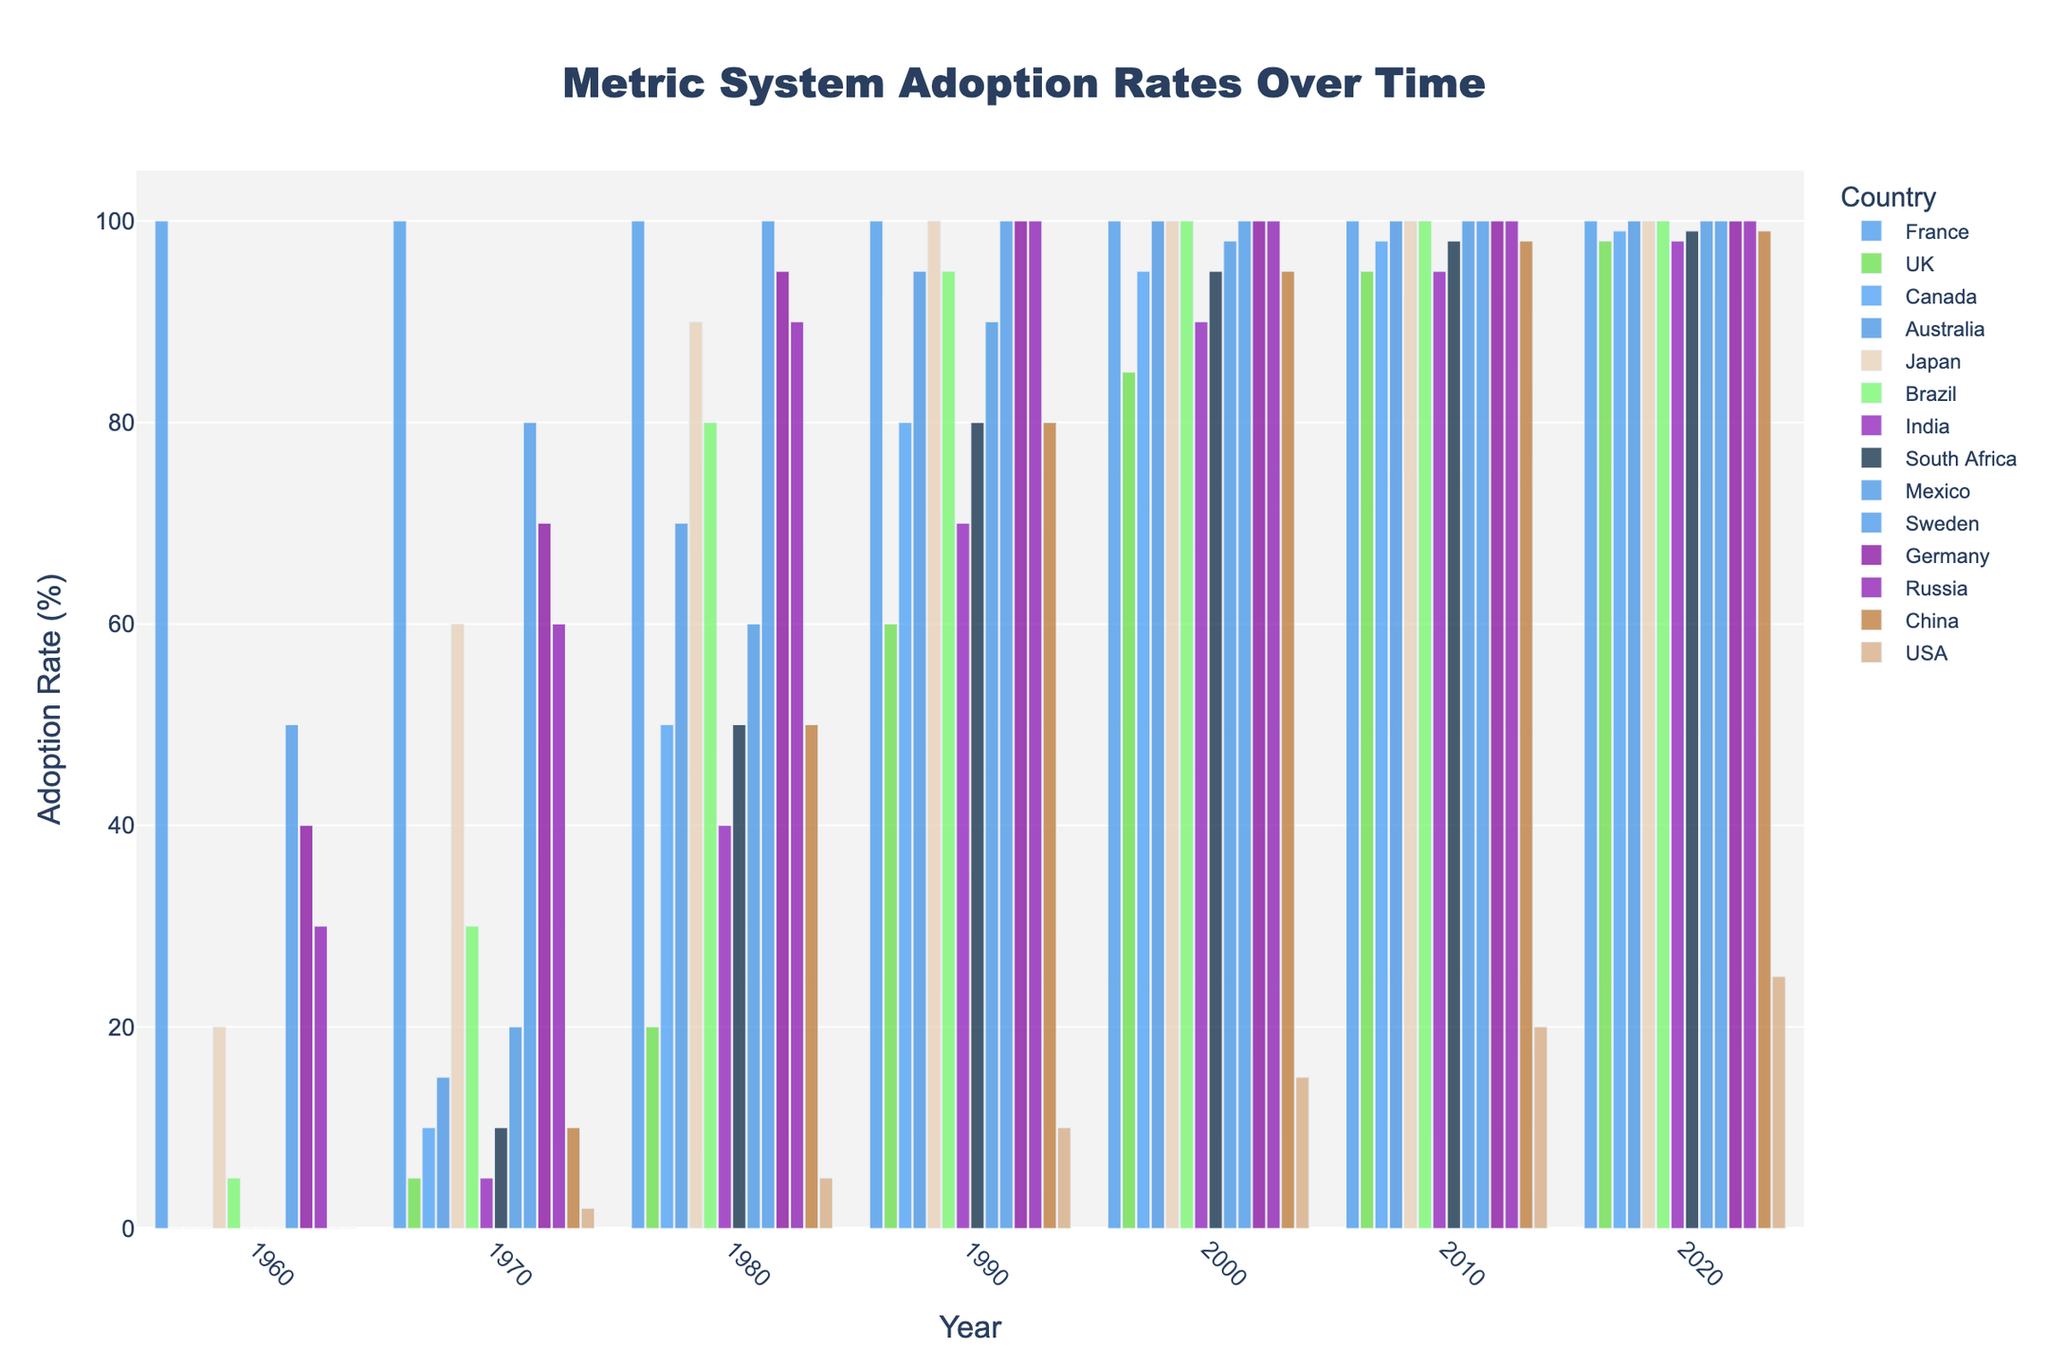Which country had the highest adoption rate of the metric system in 1960? From the figure, observe the bar heights for each country in the year 1960. France has the tallest bar, indicating 100% adoption.
Answer: France How did the adoption rate in the USA change from 1970 to 2020? Compare the bar heights for the USA in 1970 and 2020. In 1970, the adoption rate is about 2%, and in 2020, it rises to 25%. The difference is 25% - 2% = 23%.
Answer: Increased by 23% Which countries achieved 100% adoption of the metric system by 1980? Look for countries that have bars reaching the top in 1980. Only Sweden shows 100% adoption by this year.
Answer: Sweden On average, what was the adoption rate of the metric system in Mexico across all the years shown? Add the adoption rates for Mexico from 1960 to 2020 and divide by the number of data points. (0 + 20 + 60 + 90 + 98 + 100 + 100)/7 = 468/7 ≈ 66.86%.
Answer: Approximately 66.86% Did any country experience a decline in the adoption rate at any point shown in the figure? Scan the figure to check if any country's adoption rate decreases over the shown years. All countries show an increasing trend, so no country experienced a decline.
Answer: No Which two countries had the same adoption rate in 1990? Identify countries with bars of equal height in 1990. The UK and South Africa both have an 80% adoption rate in 1990.
Answer: The UK and South Africa By how much did the adoption rate increase in Brazil from 1970 to 2000? In 1970, Brazil's adoption rate is 30%; in 2000, it is 100%. The increase is 100% - 30% = 70%.
Answer: 70% How does the adoption rate of the metric system in India in 1980 compare to that in Canada? Look at the bars for 1980; India's is at 40%, and Canada's is at 50%. The adoption rate in India is 10% lower than in Canada.
Answer: 10% lower Which country showed the fastest adoption of the metric system between 1960 and 1970? Find the country with the highest differential between these years. Japan's adoption rate increased from 20% to 60%, a 40% increase.
Answer: Japan What is the difference in the metric adoption rate between Japan and the USA in 2020? From the bars, Japan has 100% adoption, and the USA has 25% in 2020. The difference is 100% - 25% = 75%.
Answer: 75% 